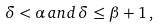<formula> <loc_0><loc_0><loc_500><loc_500>\delta < \alpha \, a n d \, \delta \leq \beta + 1 \, ,</formula> 